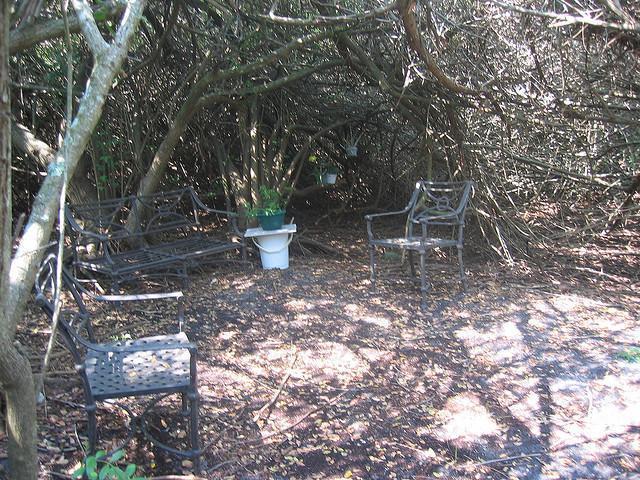How many places are there to sit down?
Give a very brief answer. 3. How many chairs can be seen?
Give a very brief answer. 2. How many zebras are shown?
Give a very brief answer. 0. 